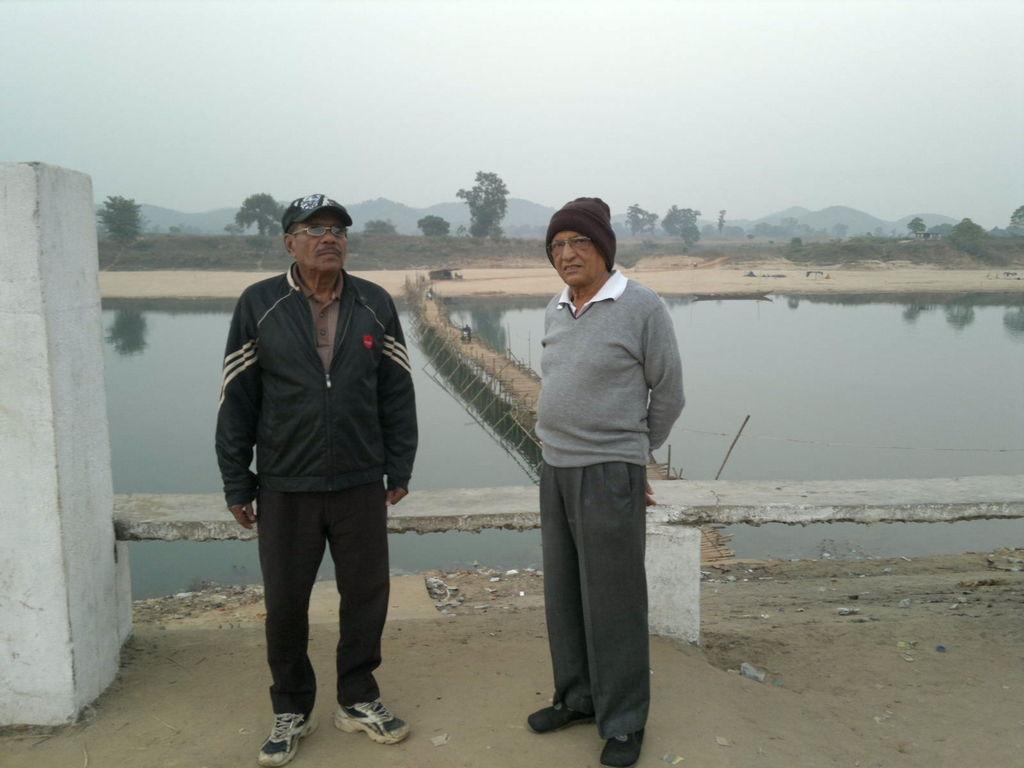In one or two sentences, can you explain what this image depicts? On the left side, there is a person in a jacket, wearing a spectacle and a cap and standing on the road. On the right side, there is another person in a gray color jacket, wearing a brown color cap, smiling and standing. Behind them, there is a bench attached to the two white color pillars. In the background, there is water, there are trees, mountains and there are clouds in the sky. 